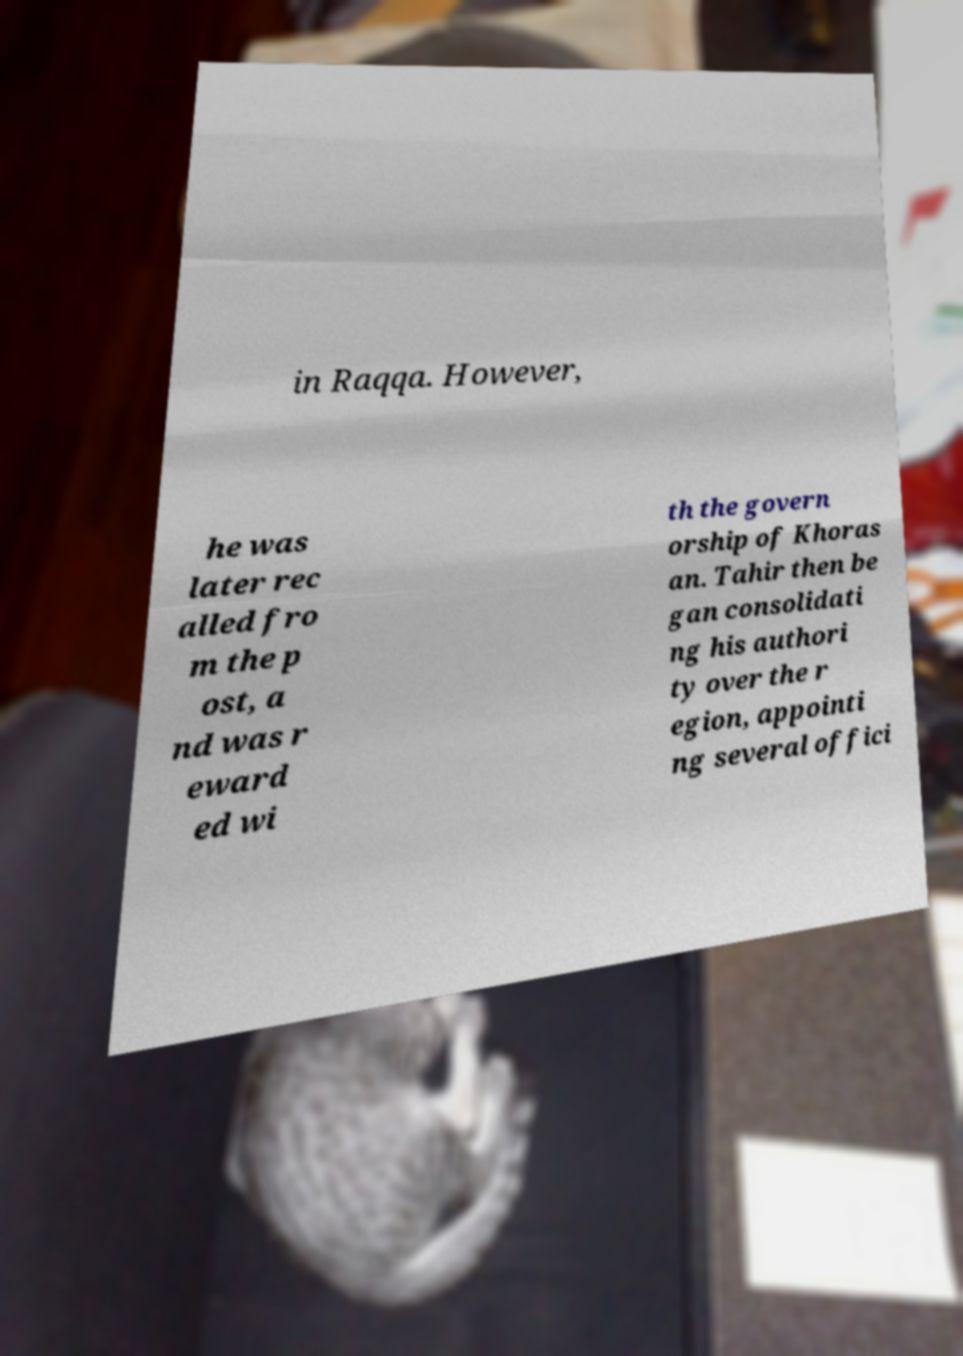Could you extract and type out the text from this image? in Raqqa. However, he was later rec alled fro m the p ost, a nd was r eward ed wi th the govern orship of Khoras an. Tahir then be gan consolidati ng his authori ty over the r egion, appointi ng several offici 